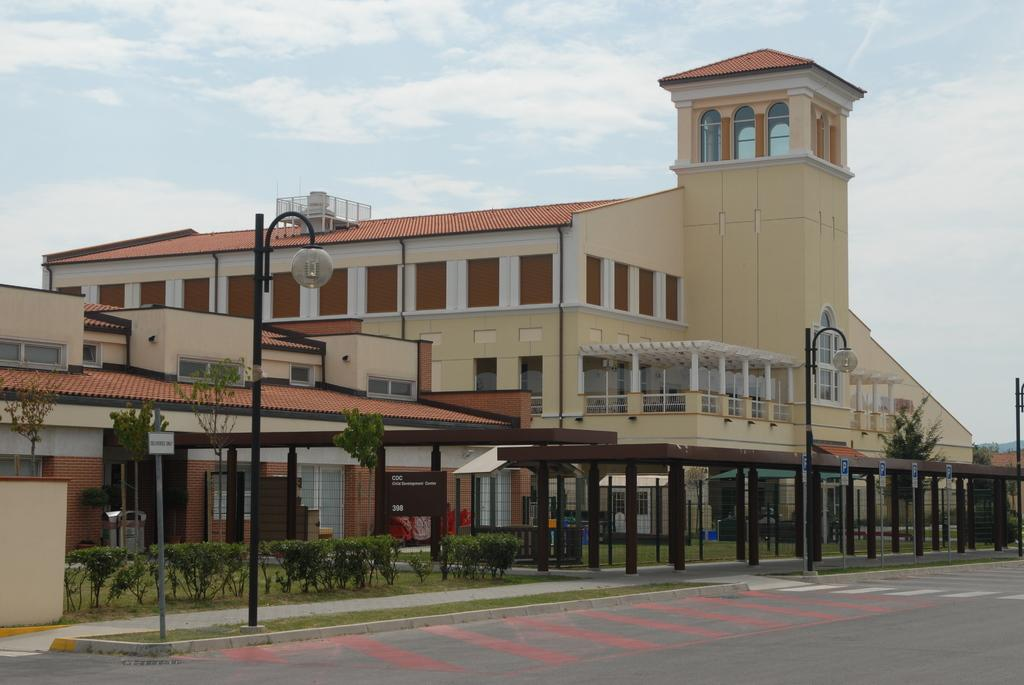What is located in the center of the image? There are buildings in the center of the image. What is at the bottom of the image? There is a road at the bottom of the image. What else can be seen in the image besides buildings and the road? There are poles, trees, and bushes visible in the image. What is visible in the background of the image? The sky is visible in the background of the image. How many suns can be seen in the image? There is no sun visible in the image; only the sky is visible in the background. What type of tub is present in the image? There is no tub present in the image. 